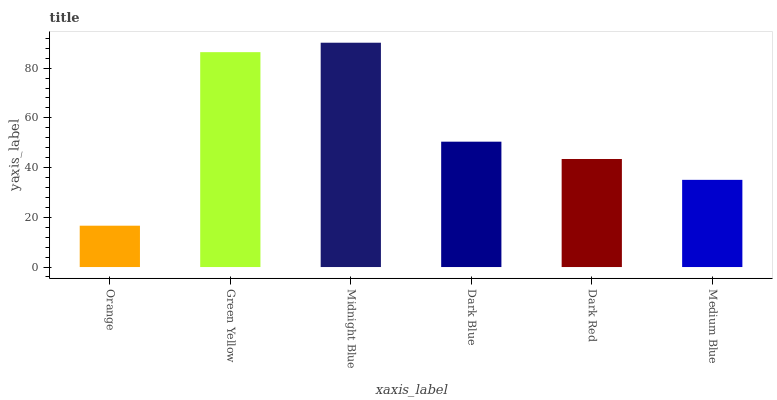Is Midnight Blue the maximum?
Answer yes or no. Yes. Is Green Yellow the minimum?
Answer yes or no. No. Is Green Yellow the maximum?
Answer yes or no. No. Is Green Yellow greater than Orange?
Answer yes or no. Yes. Is Orange less than Green Yellow?
Answer yes or no. Yes. Is Orange greater than Green Yellow?
Answer yes or no. No. Is Green Yellow less than Orange?
Answer yes or no. No. Is Dark Blue the high median?
Answer yes or no. Yes. Is Dark Red the low median?
Answer yes or no. Yes. Is Medium Blue the high median?
Answer yes or no. No. Is Midnight Blue the low median?
Answer yes or no. No. 